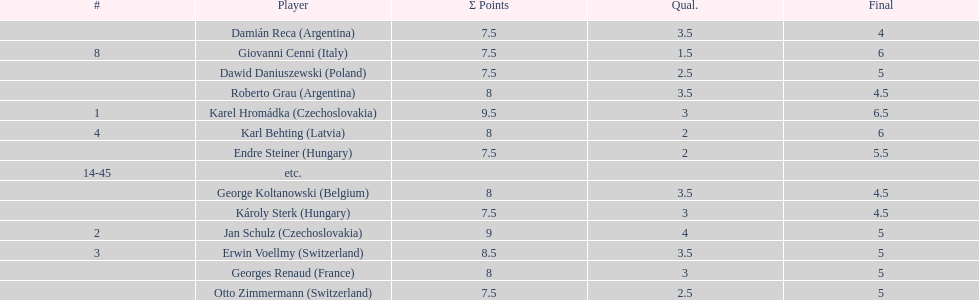Parse the table in full. {'header': ['#', 'Player', 'Σ Points', 'Qual.', 'Final'], 'rows': [['', 'Damián Reca\xa0(Argentina)', '7.5', '3.5', '4'], ['8', 'Giovanni Cenni\xa0(Italy)', '7.5', '1.5', '6'], ['', 'Dawid Daniuszewski\xa0(Poland)', '7.5', '2.5', '5'], ['', 'Roberto Grau\xa0(Argentina)', '8', '3.5', '4.5'], ['1', 'Karel Hromádka\xa0(Czechoslovakia)', '9.5', '3', '6.5'], ['4', 'Karl Behting\xa0(Latvia)', '8', '2', '6'], ['', 'Endre Steiner\xa0(Hungary)', '7.5', '2', '5.5'], ['14-45', 'etc.', '', '', ''], ['', 'George Koltanowski\xa0(Belgium)', '8', '3.5', '4.5'], ['', 'Károly Sterk\xa0(Hungary)', '7.5', '3', '4.5'], ['2', 'Jan Schulz\xa0(Czechoslovakia)', '9', '4', '5'], ['3', 'Erwin Voellmy\xa0(Switzerland)', '8.5', '3.5', '5'], ['', 'Georges Renaud\xa0(France)', '8', '3', '5'], ['', 'Otto Zimmermann\xa0(Switzerland)', '7.5', '2.5', '5']]} How many players had final scores higher than 5? 4. 